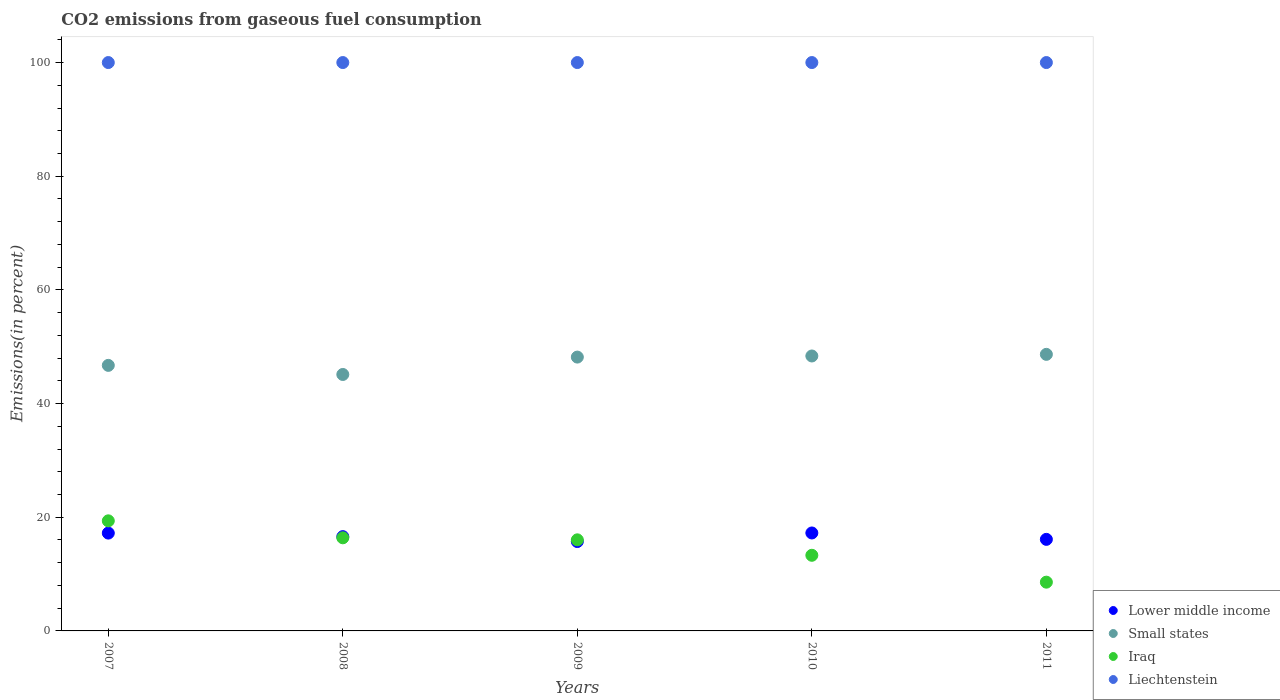How many different coloured dotlines are there?
Make the answer very short. 4. What is the total CO2 emitted in Liechtenstein in 2009?
Your answer should be very brief. 100. Across all years, what is the maximum total CO2 emitted in Iraq?
Provide a succinct answer. 19.37. Across all years, what is the minimum total CO2 emitted in Iraq?
Make the answer very short. 8.58. In which year was the total CO2 emitted in Lower middle income maximum?
Your answer should be very brief. 2010. What is the total total CO2 emitted in Iraq in the graph?
Give a very brief answer. 73.66. What is the difference between the total CO2 emitted in Iraq in 2010 and that in 2011?
Provide a short and direct response. 4.73. What is the difference between the total CO2 emitted in Liechtenstein in 2011 and the total CO2 emitted in Iraq in 2008?
Provide a short and direct response. 83.62. What is the average total CO2 emitted in Iraq per year?
Keep it short and to the point. 14.73. In the year 2007, what is the difference between the total CO2 emitted in Iraq and total CO2 emitted in Liechtenstein?
Your response must be concise. -80.63. In how many years, is the total CO2 emitted in Liechtenstein greater than 8 %?
Your answer should be compact. 5. What is the ratio of the total CO2 emitted in Iraq in 2007 to that in 2008?
Your response must be concise. 1.18. What is the difference between the highest and the second highest total CO2 emitted in Small states?
Your answer should be compact. 0.29. Is the sum of the total CO2 emitted in Liechtenstein in 2008 and 2011 greater than the maximum total CO2 emitted in Small states across all years?
Offer a terse response. Yes. Is it the case that in every year, the sum of the total CO2 emitted in Small states and total CO2 emitted in Liechtenstein  is greater than the total CO2 emitted in Lower middle income?
Give a very brief answer. Yes. Does the total CO2 emitted in Liechtenstein monotonically increase over the years?
Provide a succinct answer. No. What is the difference between two consecutive major ticks on the Y-axis?
Give a very brief answer. 20. Are the values on the major ticks of Y-axis written in scientific E-notation?
Ensure brevity in your answer.  No. How many legend labels are there?
Ensure brevity in your answer.  4. How are the legend labels stacked?
Provide a short and direct response. Vertical. What is the title of the graph?
Provide a succinct answer. CO2 emissions from gaseous fuel consumption. What is the label or title of the X-axis?
Offer a very short reply. Years. What is the label or title of the Y-axis?
Your response must be concise. Emissions(in percent). What is the Emissions(in percent) of Lower middle income in 2007?
Your answer should be compact. 17.21. What is the Emissions(in percent) in Small states in 2007?
Offer a terse response. 46.72. What is the Emissions(in percent) of Iraq in 2007?
Provide a short and direct response. 19.37. What is the Emissions(in percent) in Lower middle income in 2008?
Make the answer very short. 16.59. What is the Emissions(in percent) in Small states in 2008?
Offer a terse response. 45.12. What is the Emissions(in percent) of Iraq in 2008?
Provide a short and direct response. 16.38. What is the Emissions(in percent) of Liechtenstein in 2008?
Provide a succinct answer. 100. What is the Emissions(in percent) of Lower middle income in 2009?
Provide a succinct answer. 15.73. What is the Emissions(in percent) in Small states in 2009?
Offer a terse response. 48.18. What is the Emissions(in percent) of Iraq in 2009?
Your answer should be compact. 16.03. What is the Emissions(in percent) in Liechtenstein in 2009?
Provide a succinct answer. 100. What is the Emissions(in percent) of Lower middle income in 2010?
Keep it short and to the point. 17.23. What is the Emissions(in percent) of Small states in 2010?
Offer a terse response. 48.37. What is the Emissions(in percent) of Iraq in 2010?
Provide a short and direct response. 13.31. What is the Emissions(in percent) in Liechtenstein in 2010?
Provide a short and direct response. 100. What is the Emissions(in percent) in Lower middle income in 2011?
Provide a succinct answer. 16.11. What is the Emissions(in percent) in Small states in 2011?
Your response must be concise. 48.66. What is the Emissions(in percent) of Iraq in 2011?
Ensure brevity in your answer.  8.58. Across all years, what is the maximum Emissions(in percent) of Lower middle income?
Give a very brief answer. 17.23. Across all years, what is the maximum Emissions(in percent) in Small states?
Offer a terse response. 48.66. Across all years, what is the maximum Emissions(in percent) in Iraq?
Offer a very short reply. 19.37. Across all years, what is the maximum Emissions(in percent) in Liechtenstein?
Make the answer very short. 100. Across all years, what is the minimum Emissions(in percent) in Lower middle income?
Make the answer very short. 15.73. Across all years, what is the minimum Emissions(in percent) of Small states?
Provide a short and direct response. 45.12. Across all years, what is the minimum Emissions(in percent) in Iraq?
Provide a short and direct response. 8.58. Across all years, what is the minimum Emissions(in percent) of Liechtenstein?
Keep it short and to the point. 100. What is the total Emissions(in percent) of Lower middle income in the graph?
Provide a short and direct response. 82.87. What is the total Emissions(in percent) in Small states in the graph?
Make the answer very short. 237.05. What is the total Emissions(in percent) of Iraq in the graph?
Offer a terse response. 73.66. What is the difference between the Emissions(in percent) of Lower middle income in 2007 and that in 2008?
Offer a very short reply. 0.63. What is the difference between the Emissions(in percent) in Small states in 2007 and that in 2008?
Give a very brief answer. 1.6. What is the difference between the Emissions(in percent) in Iraq in 2007 and that in 2008?
Provide a succinct answer. 2.98. What is the difference between the Emissions(in percent) of Liechtenstein in 2007 and that in 2008?
Your answer should be very brief. 0. What is the difference between the Emissions(in percent) of Lower middle income in 2007 and that in 2009?
Your answer should be compact. 1.49. What is the difference between the Emissions(in percent) of Small states in 2007 and that in 2009?
Ensure brevity in your answer.  -1.46. What is the difference between the Emissions(in percent) of Iraq in 2007 and that in 2009?
Make the answer very short. 3.34. What is the difference between the Emissions(in percent) in Liechtenstein in 2007 and that in 2009?
Give a very brief answer. 0. What is the difference between the Emissions(in percent) of Lower middle income in 2007 and that in 2010?
Keep it short and to the point. -0.02. What is the difference between the Emissions(in percent) in Small states in 2007 and that in 2010?
Give a very brief answer. -1.65. What is the difference between the Emissions(in percent) in Iraq in 2007 and that in 2010?
Ensure brevity in your answer.  6.06. What is the difference between the Emissions(in percent) in Liechtenstein in 2007 and that in 2010?
Your answer should be very brief. 0. What is the difference between the Emissions(in percent) of Lower middle income in 2007 and that in 2011?
Keep it short and to the point. 1.1. What is the difference between the Emissions(in percent) in Small states in 2007 and that in 2011?
Make the answer very short. -1.94. What is the difference between the Emissions(in percent) of Iraq in 2007 and that in 2011?
Ensure brevity in your answer.  10.79. What is the difference between the Emissions(in percent) of Lower middle income in 2008 and that in 2009?
Offer a terse response. 0.86. What is the difference between the Emissions(in percent) of Small states in 2008 and that in 2009?
Provide a succinct answer. -3.06. What is the difference between the Emissions(in percent) of Iraq in 2008 and that in 2009?
Offer a terse response. 0.36. What is the difference between the Emissions(in percent) in Lower middle income in 2008 and that in 2010?
Provide a succinct answer. -0.65. What is the difference between the Emissions(in percent) in Small states in 2008 and that in 2010?
Keep it short and to the point. -3.25. What is the difference between the Emissions(in percent) in Iraq in 2008 and that in 2010?
Give a very brief answer. 3.08. What is the difference between the Emissions(in percent) in Lower middle income in 2008 and that in 2011?
Offer a very short reply. 0.48. What is the difference between the Emissions(in percent) in Small states in 2008 and that in 2011?
Provide a short and direct response. -3.54. What is the difference between the Emissions(in percent) of Iraq in 2008 and that in 2011?
Offer a very short reply. 7.81. What is the difference between the Emissions(in percent) in Liechtenstein in 2008 and that in 2011?
Give a very brief answer. 0. What is the difference between the Emissions(in percent) in Lower middle income in 2009 and that in 2010?
Ensure brevity in your answer.  -1.51. What is the difference between the Emissions(in percent) in Small states in 2009 and that in 2010?
Provide a short and direct response. -0.19. What is the difference between the Emissions(in percent) of Iraq in 2009 and that in 2010?
Your response must be concise. 2.72. What is the difference between the Emissions(in percent) of Liechtenstein in 2009 and that in 2010?
Offer a terse response. 0. What is the difference between the Emissions(in percent) in Lower middle income in 2009 and that in 2011?
Give a very brief answer. -0.38. What is the difference between the Emissions(in percent) in Small states in 2009 and that in 2011?
Your answer should be very brief. -0.48. What is the difference between the Emissions(in percent) in Iraq in 2009 and that in 2011?
Ensure brevity in your answer.  7.45. What is the difference between the Emissions(in percent) in Liechtenstein in 2009 and that in 2011?
Provide a short and direct response. 0. What is the difference between the Emissions(in percent) of Lower middle income in 2010 and that in 2011?
Provide a succinct answer. 1.12. What is the difference between the Emissions(in percent) in Small states in 2010 and that in 2011?
Provide a short and direct response. -0.29. What is the difference between the Emissions(in percent) in Iraq in 2010 and that in 2011?
Ensure brevity in your answer.  4.73. What is the difference between the Emissions(in percent) of Liechtenstein in 2010 and that in 2011?
Provide a short and direct response. 0. What is the difference between the Emissions(in percent) in Lower middle income in 2007 and the Emissions(in percent) in Small states in 2008?
Offer a very short reply. -27.91. What is the difference between the Emissions(in percent) in Lower middle income in 2007 and the Emissions(in percent) in Iraq in 2008?
Ensure brevity in your answer.  0.83. What is the difference between the Emissions(in percent) of Lower middle income in 2007 and the Emissions(in percent) of Liechtenstein in 2008?
Give a very brief answer. -82.79. What is the difference between the Emissions(in percent) in Small states in 2007 and the Emissions(in percent) in Iraq in 2008?
Provide a succinct answer. 30.34. What is the difference between the Emissions(in percent) in Small states in 2007 and the Emissions(in percent) in Liechtenstein in 2008?
Your response must be concise. -53.28. What is the difference between the Emissions(in percent) of Iraq in 2007 and the Emissions(in percent) of Liechtenstein in 2008?
Give a very brief answer. -80.63. What is the difference between the Emissions(in percent) in Lower middle income in 2007 and the Emissions(in percent) in Small states in 2009?
Your answer should be compact. -30.97. What is the difference between the Emissions(in percent) in Lower middle income in 2007 and the Emissions(in percent) in Iraq in 2009?
Keep it short and to the point. 1.19. What is the difference between the Emissions(in percent) of Lower middle income in 2007 and the Emissions(in percent) of Liechtenstein in 2009?
Give a very brief answer. -82.79. What is the difference between the Emissions(in percent) of Small states in 2007 and the Emissions(in percent) of Iraq in 2009?
Offer a very short reply. 30.7. What is the difference between the Emissions(in percent) of Small states in 2007 and the Emissions(in percent) of Liechtenstein in 2009?
Keep it short and to the point. -53.28. What is the difference between the Emissions(in percent) in Iraq in 2007 and the Emissions(in percent) in Liechtenstein in 2009?
Provide a short and direct response. -80.63. What is the difference between the Emissions(in percent) of Lower middle income in 2007 and the Emissions(in percent) of Small states in 2010?
Provide a succinct answer. -31.16. What is the difference between the Emissions(in percent) in Lower middle income in 2007 and the Emissions(in percent) in Iraq in 2010?
Your answer should be compact. 3.91. What is the difference between the Emissions(in percent) in Lower middle income in 2007 and the Emissions(in percent) in Liechtenstein in 2010?
Give a very brief answer. -82.79. What is the difference between the Emissions(in percent) in Small states in 2007 and the Emissions(in percent) in Iraq in 2010?
Your answer should be very brief. 33.42. What is the difference between the Emissions(in percent) in Small states in 2007 and the Emissions(in percent) in Liechtenstein in 2010?
Give a very brief answer. -53.28. What is the difference between the Emissions(in percent) of Iraq in 2007 and the Emissions(in percent) of Liechtenstein in 2010?
Give a very brief answer. -80.63. What is the difference between the Emissions(in percent) in Lower middle income in 2007 and the Emissions(in percent) in Small states in 2011?
Offer a terse response. -31.45. What is the difference between the Emissions(in percent) in Lower middle income in 2007 and the Emissions(in percent) in Iraq in 2011?
Provide a succinct answer. 8.63. What is the difference between the Emissions(in percent) of Lower middle income in 2007 and the Emissions(in percent) of Liechtenstein in 2011?
Provide a short and direct response. -82.79. What is the difference between the Emissions(in percent) in Small states in 2007 and the Emissions(in percent) in Iraq in 2011?
Offer a very short reply. 38.14. What is the difference between the Emissions(in percent) of Small states in 2007 and the Emissions(in percent) of Liechtenstein in 2011?
Give a very brief answer. -53.28. What is the difference between the Emissions(in percent) in Iraq in 2007 and the Emissions(in percent) in Liechtenstein in 2011?
Ensure brevity in your answer.  -80.63. What is the difference between the Emissions(in percent) of Lower middle income in 2008 and the Emissions(in percent) of Small states in 2009?
Provide a short and direct response. -31.59. What is the difference between the Emissions(in percent) of Lower middle income in 2008 and the Emissions(in percent) of Iraq in 2009?
Offer a terse response. 0.56. What is the difference between the Emissions(in percent) of Lower middle income in 2008 and the Emissions(in percent) of Liechtenstein in 2009?
Your answer should be very brief. -83.41. What is the difference between the Emissions(in percent) in Small states in 2008 and the Emissions(in percent) in Iraq in 2009?
Keep it short and to the point. 29.09. What is the difference between the Emissions(in percent) in Small states in 2008 and the Emissions(in percent) in Liechtenstein in 2009?
Offer a very short reply. -54.88. What is the difference between the Emissions(in percent) of Iraq in 2008 and the Emissions(in percent) of Liechtenstein in 2009?
Your answer should be compact. -83.62. What is the difference between the Emissions(in percent) of Lower middle income in 2008 and the Emissions(in percent) of Small states in 2010?
Provide a succinct answer. -31.79. What is the difference between the Emissions(in percent) in Lower middle income in 2008 and the Emissions(in percent) in Iraq in 2010?
Your answer should be compact. 3.28. What is the difference between the Emissions(in percent) in Lower middle income in 2008 and the Emissions(in percent) in Liechtenstein in 2010?
Offer a very short reply. -83.41. What is the difference between the Emissions(in percent) of Small states in 2008 and the Emissions(in percent) of Iraq in 2010?
Offer a very short reply. 31.81. What is the difference between the Emissions(in percent) in Small states in 2008 and the Emissions(in percent) in Liechtenstein in 2010?
Ensure brevity in your answer.  -54.88. What is the difference between the Emissions(in percent) in Iraq in 2008 and the Emissions(in percent) in Liechtenstein in 2010?
Offer a terse response. -83.62. What is the difference between the Emissions(in percent) in Lower middle income in 2008 and the Emissions(in percent) in Small states in 2011?
Offer a terse response. -32.07. What is the difference between the Emissions(in percent) of Lower middle income in 2008 and the Emissions(in percent) of Iraq in 2011?
Your answer should be very brief. 8.01. What is the difference between the Emissions(in percent) of Lower middle income in 2008 and the Emissions(in percent) of Liechtenstein in 2011?
Make the answer very short. -83.41. What is the difference between the Emissions(in percent) of Small states in 2008 and the Emissions(in percent) of Iraq in 2011?
Provide a succinct answer. 36.54. What is the difference between the Emissions(in percent) in Small states in 2008 and the Emissions(in percent) in Liechtenstein in 2011?
Your answer should be very brief. -54.88. What is the difference between the Emissions(in percent) in Iraq in 2008 and the Emissions(in percent) in Liechtenstein in 2011?
Provide a short and direct response. -83.62. What is the difference between the Emissions(in percent) of Lower middle income in 2009 and the Emissions(in percent) of Small states in 2010?
Offer a very short reply. -32.65. What is the difference between the Emissions(in percent) of Lower middle income in 2009 and the Emissions(in percent) of Iraq in 2010?
Keep it short and to the point. 2.42. What is the difference between the Emissions(in percent) of Lower middle income in 2009 and the Emissions(in percent) of Liechtenstein in 2010?
Offer a very short reply. -84.27. What is the difference between the Emissions(in percent) in Small states in 2009 and the Emissions(in percent) in Iraq in 2010?
Your response must be concise. 34.87. What is the difference between the Emissions(in percent) in Small states in 2009 and the Emissions(in percent) in Liechtenstein in 2010?
Offer a terse response. -51.82. What is the difference between the Emissions(in percent) of Iraq in 2009 and the Emissions(in percent) of Liechtenstein in 2010?
Offer a terse response. -83.97. What is the difference between the Emissions(in percent) of Lower middle income in 2009 and the Emissions(in percent) of Small states in 2011?
Offer a very short reply. -32.93. What is the difference between the Emissions(in percent) in Lower middle income in 2009 and the Emissions(in percent) in Iraq in 2011?
Make the answer very short. 7.15. What is the difference between the Emissions(in percent) of Lower middle income in 2009 and the Emissions(in percent) of Liechtenstein in 2011?
Your answer should be very brief. -84.27. What is the difference between the Emissions(in percent) of Small states in 2009 and the Emissions(in percent) of Iraq in 2011?
Offer a very short reply. 39.6. What is the difference between the Emissions(in percent) in Small states in 2009 and the Emissions(in percent) in Liechtenstein in 2011?
Provide a short and direct response. -51.82. What is the difference between the Emissions(in percent) of Iraq in 2009 and the Emissions(in percent) of Liechtenstein in 2011?
Give a very brief answer. -83.97. What is the difference between the Emissions(in percent) in Lower middle income in 2010 and the Emissions(in percent) in Small states in 2011?
Keep it short and to the point. -31.43. What is the difference between the Emissions(in percent) in Lower middle income in 2010 and the Emissions(in percent) in Iraq in 2011?
Ensure brevity in your answer.  8.65. What is the difference between the Emissions(in percent) in Lower middle income in 2010 and the Emissions(in percent) in Liechtenstein in 2011?
Give a very brief answer. -82.77. What is the difference between the Emissions(in percent) of Small states in 2010 and the Emissions(in percent) of Iraq in 2011?
Make the answer very short. 39.79. What is the difference between the Emissions(in percent) of Small states in 2010 and the Emissions(in percent) of Liechtenstein in 2011?
Offer a terse response. -51.63. What is the difference between the Emissions(in percent) in Iraq in 2010 and the Emissions(in percent) in Liechtenstein in 2011?
Give a very brief answer. -86.69. What is the average Emissions(in percent) in Lower middle income per year?
Your answer should be compact. 16.57. What is the average Emissions(in percent) of Small states per year?
Keep it short and to the point. 47.41. What is the average Emissions(in percent) of Iraq per year?
Provide a short and direct response. 14.73. What is the average Emissions(in percent) in Liechtenstein per year?
Provide a succinct answer. 100. In the year 2007, what is the difference between the Emissions(in percent) of Lower middle income and Emissions(in percent) of Small states?
Ensure brevity in your answer.  -29.51. In the year 2007, what is the difference between the Emissions(in percent) in Lower middle income and Emissions(in percent) in Iraq?
Provide a short and direct response. -2.16. In the year 2007, what is the difference between the Emissions(in percent) of Lower middle income and Emissions(in percent) of Liechtenstein?
Keep it short and to the point. -82.79. In the year 2007, what is the difference between the Emissions(in percent) of Small states and Emissions(in percent) of Iraq?
Make the answer very short. 27.35. In the year 2007, what is the difference between the Emissions(in percent) of Small states and Emissions(in percent) of Liechtenstein?
Your answer should be compact. -53.28. In the year 2007, what is the difference between the Emissions(in percent) in Iraq and Emissions(in percent) in Liechtenstein?
Make the answer very short. -80.63. In the year 2008, what is the difference between the Emissions(in percent) in Lower middle income and Emissions(in percent) in Small states?
Your answer should be very brief. -28.53. In the year 2008, what is the difference between the Emissions(in percent) of Lower middle income and Emissions(in percent) of Iraq?
Your answer should be compact. 0.2. In the year 2008, what is the difference between the Emissions(in percent) in Lower middle income and Emissions(in percent) in Liechtenstein?
Offer a very short reply. -83.41. In the year 2008, what is the difference between the Emissions(in percent) in Small states and Emissions(in percent) in Iraq?
Your response must be concise. 28.74. In the year 2008, what is the difference between the Emissions(in percent) of Small states and Emissions(in percent) of Liechtenstein?
Ensure brevity in your answer.  -54.88. In the year 2008, what is the difference between the Emissions(in percent) of Iraq and Emissions(in percent) of Liechtenstein?
Your response must be concise. -83.62. In the year 2009, what is the difference between the Emissions(in percent) in Lower middle income and Emissions(in percent) in Small states?
Your answer should be very brief. -32.45. In the year 2009, what is the difference between the Emissions(in percent) in Lower middle income and Emissions(in percent) in Iraq?
Keep it short and to the point. -0.3. In the year 2009, what is the difference between the Emissions(in percent) of Lower middle income and Emissions(in percent) of Liechtenstein?
Keep it short and to the point. -84.27. In the year 2009, what is the difference between the Emissions(in percent) in Small states and Emissions(in percent) in Iraq?
Offer a terse response. 32.15. In the year 2009, what is the difference between the Emissions(in percent) of Small states and Emissions(in percent) of Liechtenstein?
Your answer should be compact. -51.82. In the year 2009, what is the difference between the Emissions(in percent) in Iraq and Emissions(in percent) in Liechtenstein?
Offer a very short reply. -83.97. In the year 2010, what is the difference between the Emissions(in percent) in Lower middle income and Emissions(in percent) in Small states?
Provide a succinct answer. -31.14. In the year 2010, what is the difference between the Emissions(in percent) in Lower middle income and Emissions(in percent) in Iraq?
Ensure brevity in your answer.  3.93. In the year 2010, what is the difference between the Emissions(in percent) in Lower middle income and Emissions(in percent) in Liechtenstein?
Your answer should be very brief. -82.77. In the year 2010, what is the difference between the Emissions(in percent) of Small states and Emissions(in percent) of Iraq?
Ensure brevity in your answer.  35.07. In the year 2010, what is the difference between the Emissions(in percent) in Small states and Emissions(in percent) in Liechtenstein?
Provide a succinct answer. -51.63. In the year 2010, what is the difference between the Emissions(in percent) of Iraq and Emissions(in percent) of Liechtenstein?
Provide a succinct answer. -86.69. In the year 2011, what is the difference between the Emissions(in percent) of Lower middle income and Emissions(in percent) of Small states?
Ensure brevity in your answer.  -32.55. In the year 2011, what is the difference between the Emissions(in percent) in Lower middle income and Emissions(in percent) in Iraq?
Your answer should be very brief. 7.53. In the year 2011, what is the difference between the Emissions(in percent) in Lower middle income and Emissions(in percent) in Liechtenstein?
Your response must be concise. -83.89. In the year 2011, what is the difference between the Emissions(in percent) in Small states and Emissions(in percent) in Iraq?
Provide a short and direct response. 40.08. In the year 2011, what is the difference between the Emissions(in percent) in Small states and Emissions(in percent) in Liechtenstein?
Your answer should be compact. -51.34. In the year 2011, what is the difference between the Emissions(in percent) in Iraq and Emissions(in percent) in Liechtenstein?
Offer a very short reply. -91.42. What is the ratio of the Emissions(in percent) of Lower middle income in 2007 to that in 2008?
Your answer should be very brief. 1.04. What is the ratio of the Emissions(in percent) of Small states in 2007 to that in 2008?
Provide a succinct answer. 1.04. What is the ratio of the Emissions(in percent) in Iraq in 2007 to that in 2008?
Your answer should be compact. 1.18. What is the ratio of the Emissions(in percent) of Lower middle income in 2007 to that in 2009?
Your response must be concise. 1.09. What is the ratio of the Emissions(in percent) in Small states in 2007 to that in 2009?
Your response must be concise. 0.97. What is the ratio of the Emissions(in percent) in Iraq in 2007 to that in 2009?
Your answer should be very brief. 1.21. What is the ratio of the Emissions(in percent) in Liechtenstein in 2007 to that in 2009?
Ensure brevity in your answer.  1. What is the ratio of the Emissions(in percent) in Small states in 2007 to that in 2010?
Keep it short and to the point. 0.97. What is the ratio of the Emissions(in percent) of Iraq in 2007 to that in 2010?
Provide a succinct answer. 1.46. What is the ratio of the Emissions(in percent) of Liechtenstein in 2007 to that in 2010?
Keep it short and to the point. 1. What is the ratio of the Emissions(in percent) of Lower middle income in 2007 to that in 2011?
Keep it short and to the point. 1.07. What is the ratio of the Emissions(in percent) of Small states in 2007 to that in 2011?
Your answer should be compact. 0.96. What is the ratio of the Emissions(in percent) in Iraq in 2007 to that in 2011?
Provide a short and direct response. 2.26. What is the ratio of the Emissions(in percent) in Liechtenstein in 2007 to that in 2011?
Provide a succinct answer. 1. What is the ratio of the Emissions(in percent) in Lower middle income in 2008 to that in 2009?
Provide a succinct answer. 1.05. What is the ratio of the Emissions(in percent) of Small states in 2008 to that in 2009?
Offer a very short reply. 0.94. What is the ratio of the Emissions(in percent) in Iraq in 2008 to that in 2009?
Your response must be concise. 1.02. What is the ratio of the Emissions(in percent) in Liechtenstein in 2008 to that in 2009?
Make the answer very short. 1. What is the ratio of the Emissions(in percent) of Lower middle income in 2008 to that in 2010?
Ensure brevity in your answer.  0.96. What is the ratio of the Emissions(in percent) in Small states in 2008 to that in 2010?
Ensure brevity in your answer.  0.93. What is the ratio of the Emissions(in percent) in Iraq in 2008 to that in 2010?
Give a very brief answer. 1.23. What is the ratio of the Emissions(in percent) in Lower middle income in 2008 to that in 2011?
Your answer should be very brief. 1.03. What is the ratio of the Emissions(in percent) in Small states in 2008 to that in 2011?
Your answer should be compact. 0.93. What is the ratio of the Emissions(in percent) in Iraq in 2008 to that in 2011?
Give a very brief answer. 1.91. What is the ratio of the Emissions(in percent) in Lower middle income in 2009 to that in 2010?
Your answer should be compact. 0.91. What is the ratio of the Emissions(in percent) of Iraq in 2009 to that in 2010?
Your response must be concise. 1.2. What is the ratio of the Emissions(in percent) in Liechtenstein in 2009 to that in 2010?
Offer a terse response. 1. What is the ratio of the Emissions(in percent) in Lower middle income in 2009 to that in 2011?
Your answer should be very brief. 0.98. What is the ratio of the Emissions(in percent) of Small states in 2009 to that in 2011?
Give a very brief answer. 0.99. What is the ratio of the Emissions(in percent) in Iraq in 2009 to that in 2011?
Your response must be concise. 1.87. What is the ratio of the Emissions(in percent) of Liechtenstein in 2009 to that in 2011?
Offer a terse response. 1. What is the ratio of the Emissions(in percent) of Lower middle income in 2010 to that in 2011?
Give a very brief answer. 1.07. What is the ratio of the Emissions(in percent) of Iraq in 2010 to that in 2011?
Give a very brief answer. 1.55. What is the difference between the highest and the second highest Emissions(in percent) of Lower middle income?
Provide a short and direct response. 0.02. What is the difference between the highest and the second highest Emissions(in percent) in Small states?
Your response must be concise. 0.29. What is the difference between the highest and the second highest Emissions(in percent) in Iraq?
Offer a very short reply. 2.98. What is the difference between the highest and the second highest Emissions(in percent) in Liechtenstein?
Provide a short and direct response. 0. What is the difference between the highest and the lowest Emissions(in percent) of Lower middle income?
Provide a short and direct response. 1.51. What is the difference between the highest and the lowest Emissions(in percent) in Small states?
Ensure brevity in your answer.  3.54. What is the difference between the highest and the lowest Emissions(in percent) in Iraq?
Provide a succinct answer. 10.79. 